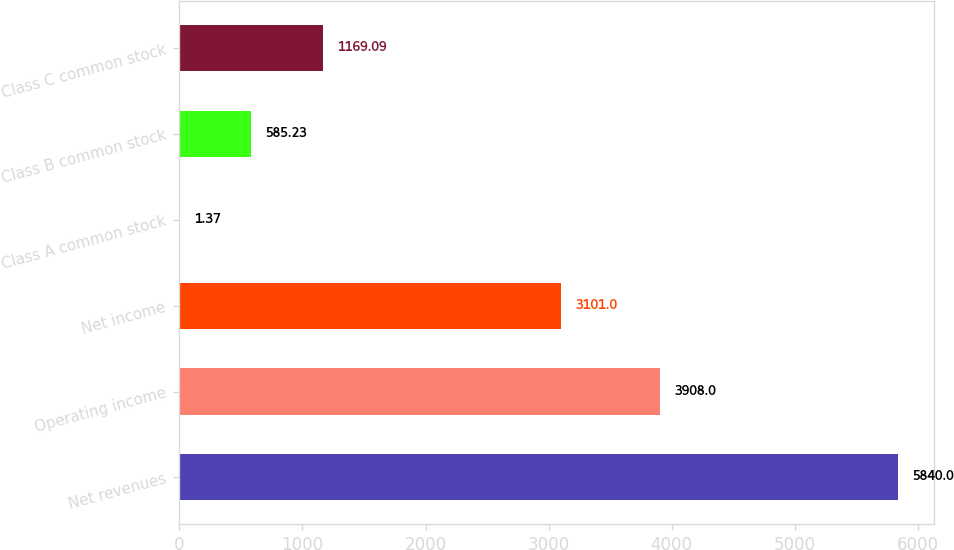Convert chart to OTSL. <chart><loc_0><loc_0><loc_500><loc_500><bar_chart><fcel>Net revenues<fcel>Operating income<fcel>Net income<fcel>Class A common stock<fcel>Class B common stock<fcel>Class C common stock<nl><fcel>5840<fcel>3908<fcel>3101<fcel>1.37<fcel>585.23<fcel>1169.09<nl></chart> 